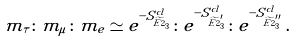<formula> <loc_0><loc_0><loc_500><loc_500>m _ { \tau } \colon m _ { \mu } \colon m _ { e } \simeq e ^ { - S ^ { c l } _ { \widetilde { E 2 } _ { 3 } } } \colon e ^ { - S ^ { c l } _ { \widetilde { E 2 } ^ { \prime } _ { 3 } } } \colon e ^ { - S ^ { c l } _ { \widetilde { E 2 } ^ { \prime \prime } _ { 3 } } } \, .</formula> 